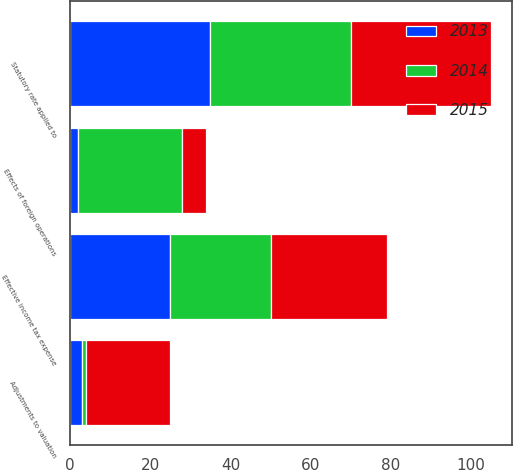Convert chart to OTSL. <chart><loc_0><loc_0><loc_500><loc_500><stacked_bar_chart><ecel><fcel>Statutory rate applied to<fcel>Effects of foreign operations<fcel>Adjustments to valuation<fcel>Effective income tax expense<nl><fcel>2013<fcel>35<fcel>2<fcel>3<fcel>25<nl><fcel>2015<fcel>35<fcel>6<fcel>21<fcel>29<nl><fcel>2014<fcel>35<fcel>26<fcel>1<fcel>25<nl></chart> 